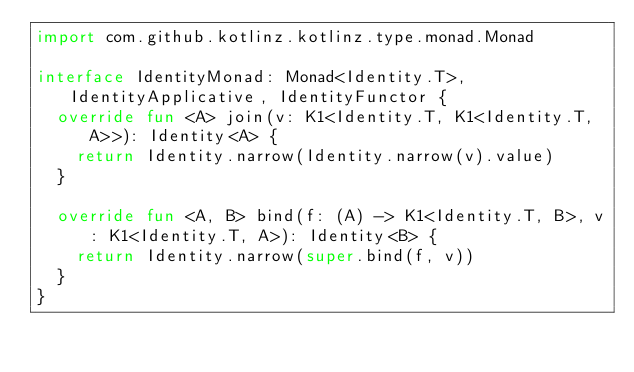<code> <loc_0><loc_0><loc_500><loc_500><_Kotlin_>import com.github.kotlinz.kotlinz.type.monad.Monad

interface IdentityMonad: Monad<Identity.T>, IdentityApplicative, IdentityFunctor {
  override fun <A> join(v: K1<Identity.T, K1<Identity.T, A>>): Identity<A> {
    return Identity.narrow(Identity.narrow(v).value)
  }

  override fun <A, B> bind(f: (A) -> K1<Identity.T, B>, v: K1<Identity.T, A>): Identity<B> {
    return Identity.narrow(super.bind(f, v))
  }
}
</code> 